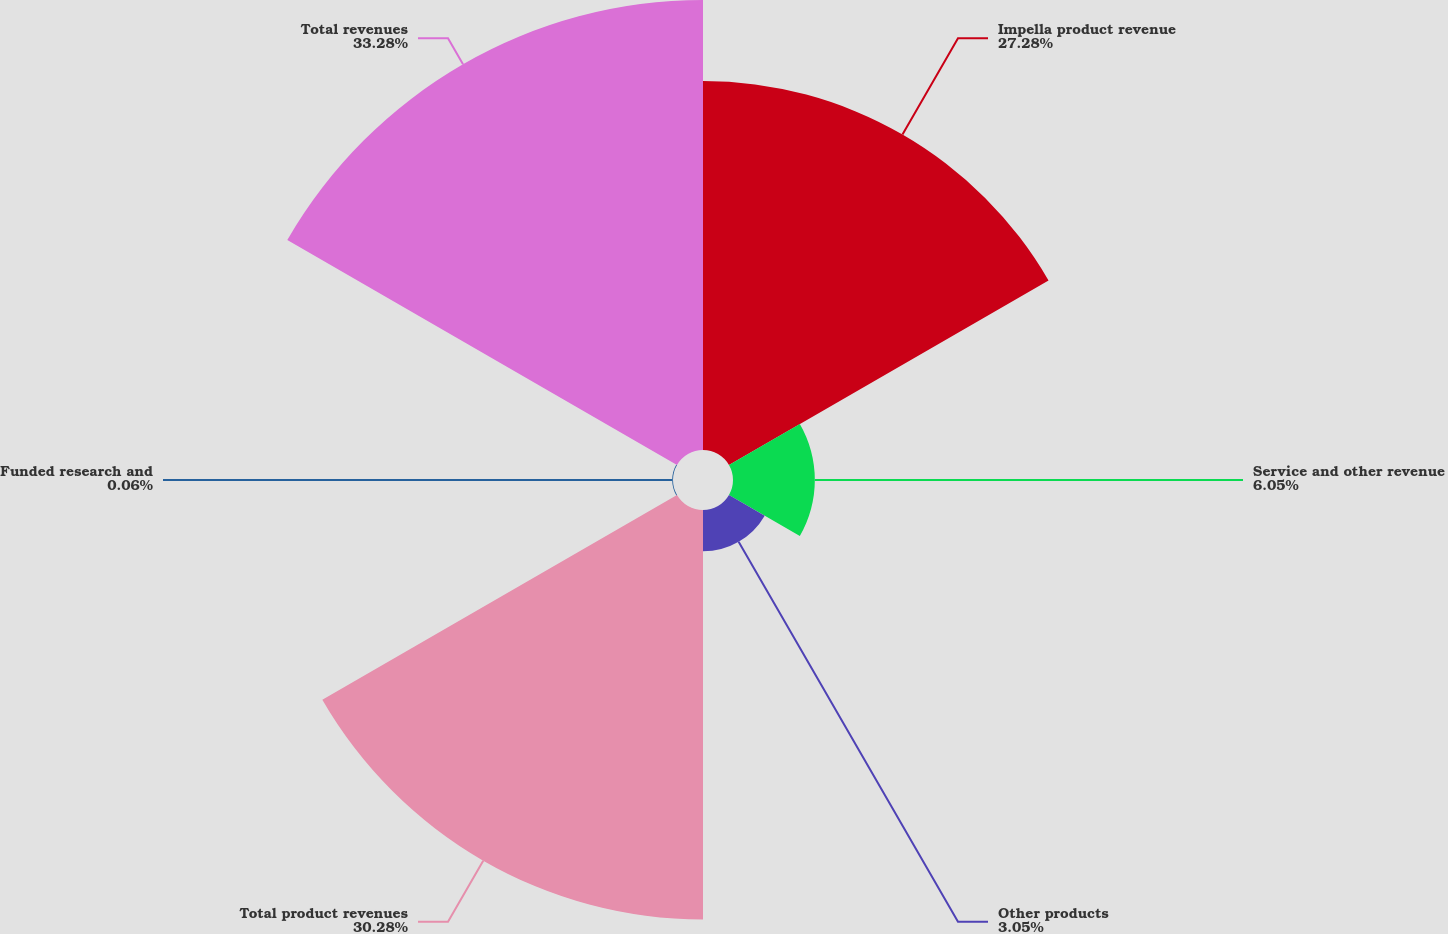Convert chart. <chart><loc_0><loc_0><loc_500><loc_500><pie_chart><fcel>Impella product revenue<fcel>Service and other revenue<fcel>Other products<fcel>Total product revenues<fcel>Funded research and<fcel>Total revenues<nl><fcel>27.28%<fcel>6.05%<fcel>3.05%<fcel>30.28%<fcel>0.06%<fcel>33.27%<nl></chart> 